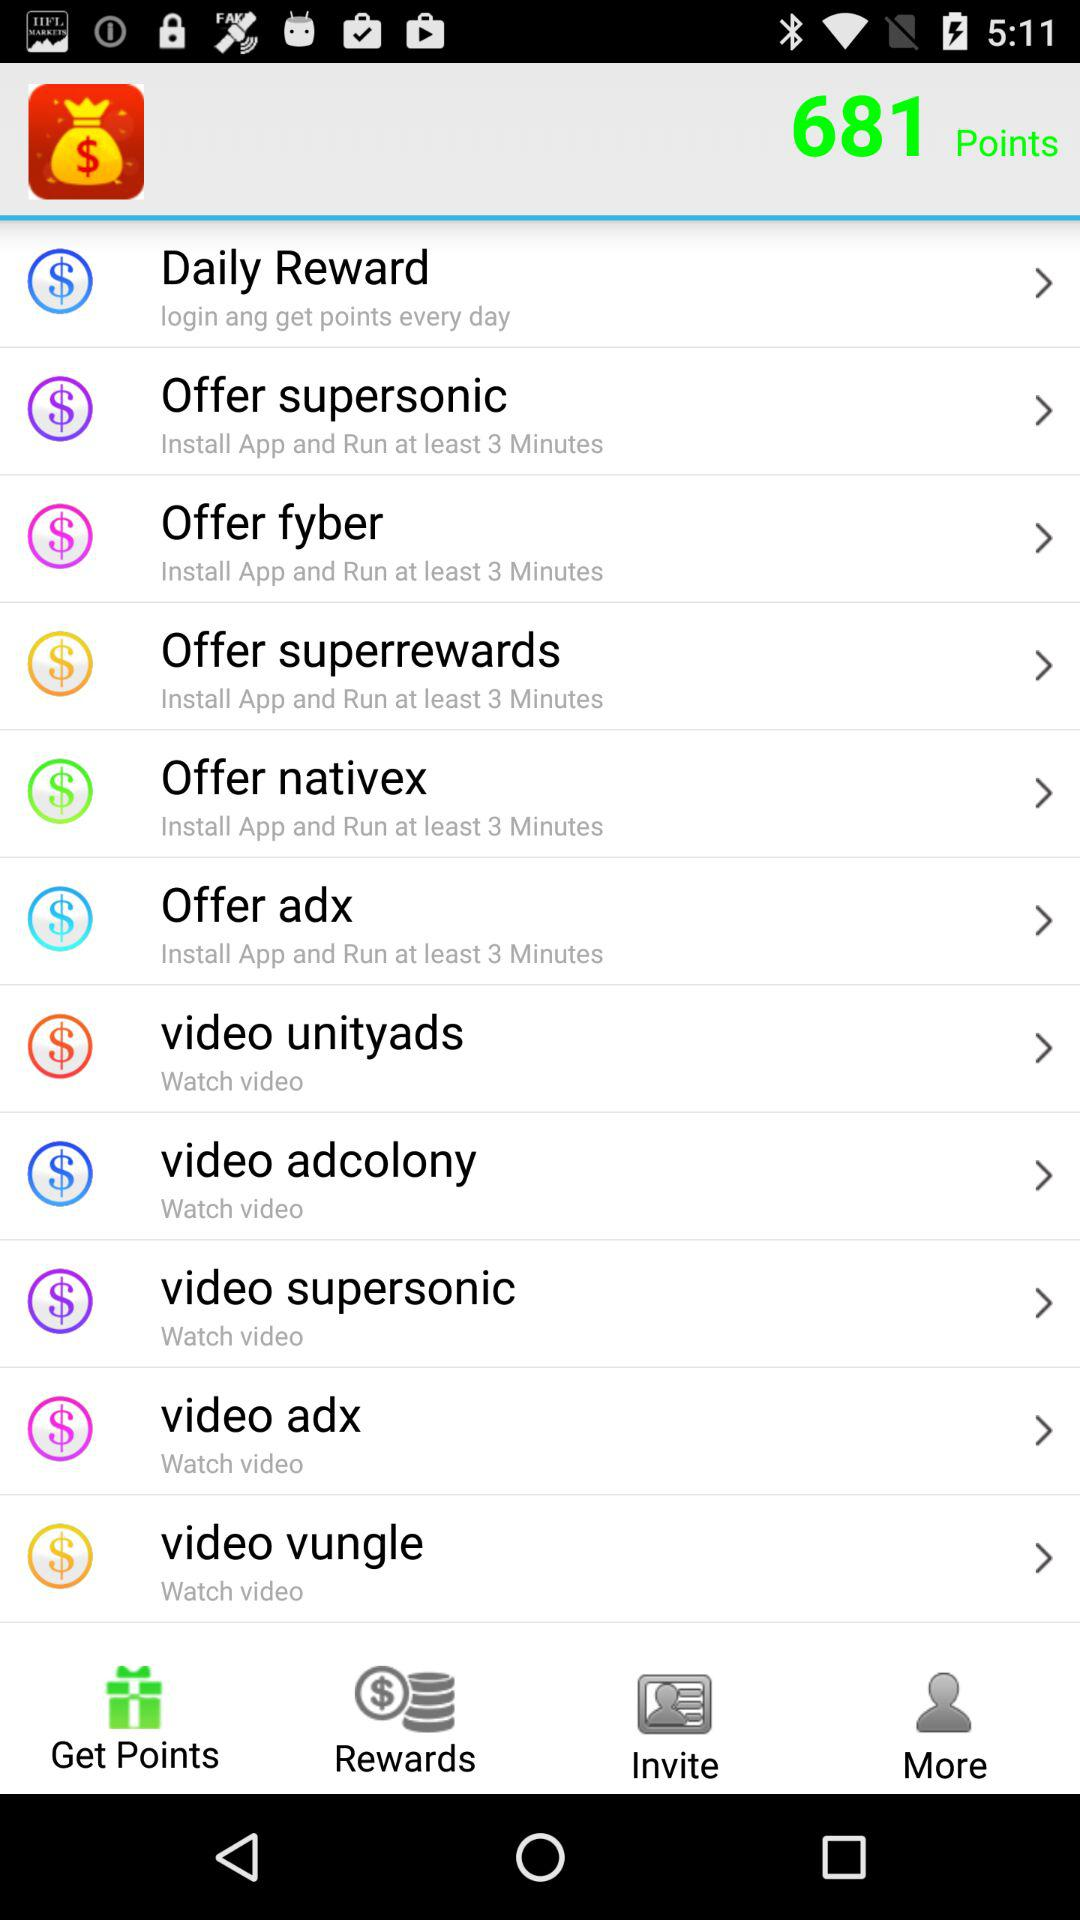Which tab is open? The open tab is "Get Points". 